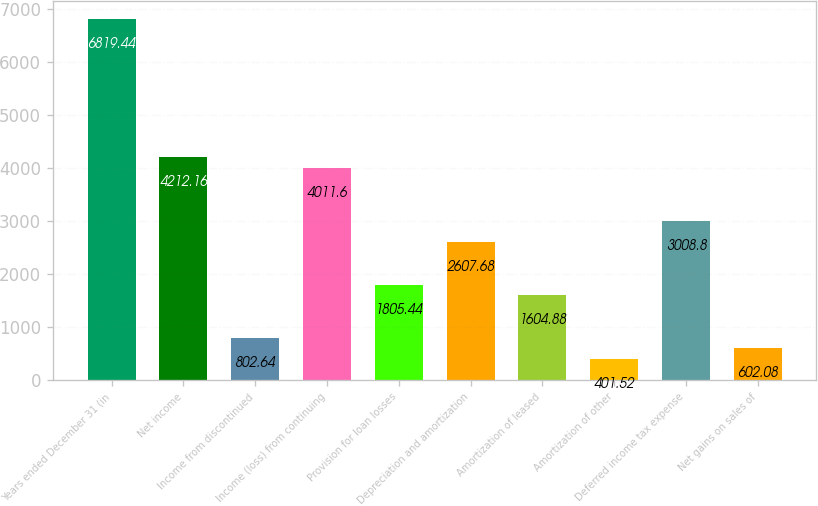Convert chart to OTSL. <chart><loc_0><loc_0><loc_500><loc_500><bar_chart><fcel>Years ended December 31 (in<fcel>Net income<fcel>Income from discontinued<fcel>Income (loss) from continuing<fcel>Provision for loan losses<fcel>Depreciation and amortization<fcel>Amortization of leased<fcel>Amortization of other<fcel>Deferred income tax expense<fcel>Net gains on sales of<nl><fcel>6819.44<fcel>4212.16<fcel>802.64<fcel>4011.6<fcel>1805.44<fcel>2607.68<fcel>1604.88<fcel>401.52<fcel>3008.8<fcel>602.08<nl></chart> 